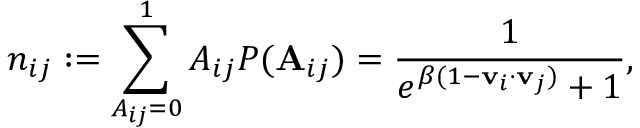Convert formula to latex. <formula><loc_0><loc_0><loc_500><loc_500>n _ { i j } \colon = \sum _ { A _ { i j } = 0 } ^ { 1 } A _ { i j } P ( \mathbf A _ { i j } ) = \frac { 1 } { e ^ { \beta ( 1 - v _ { i } \cdot v _ { j } ) } + 1 } ,</formula> 